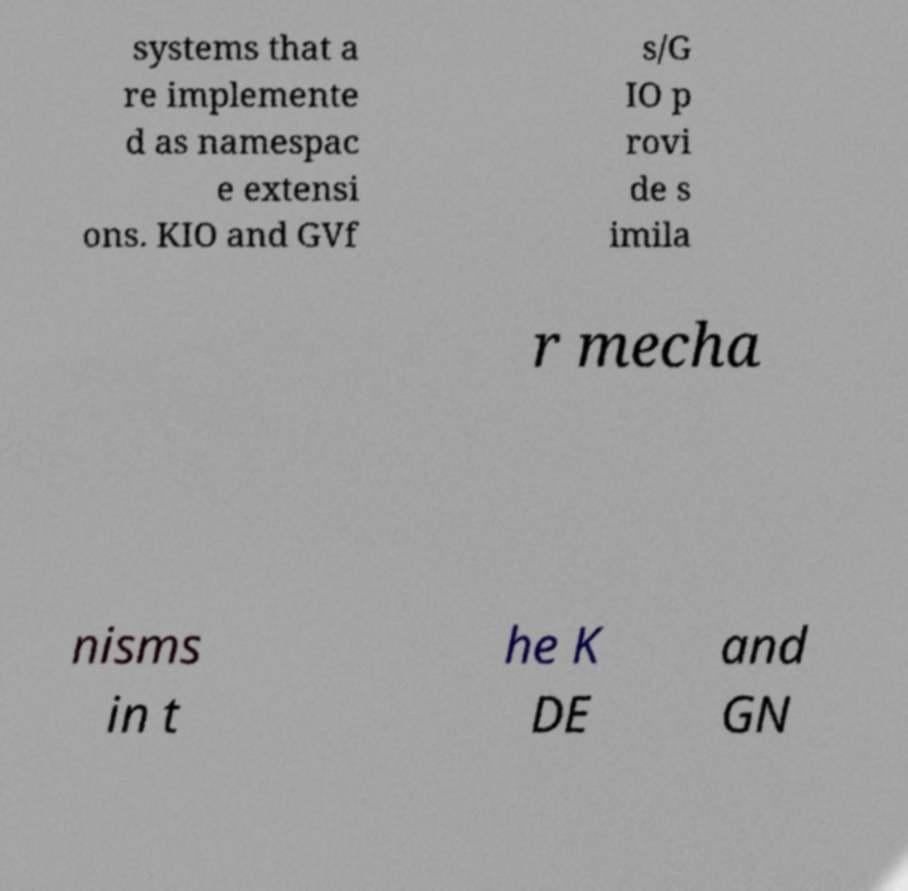What messages or text are displayed in this image? I need them in a readable, typed format. systems that a re implemente d as namespac e extensi ons. KIO and GVf s/G IO p rovi de s imila r mecha nisms in t he K DE and GN 